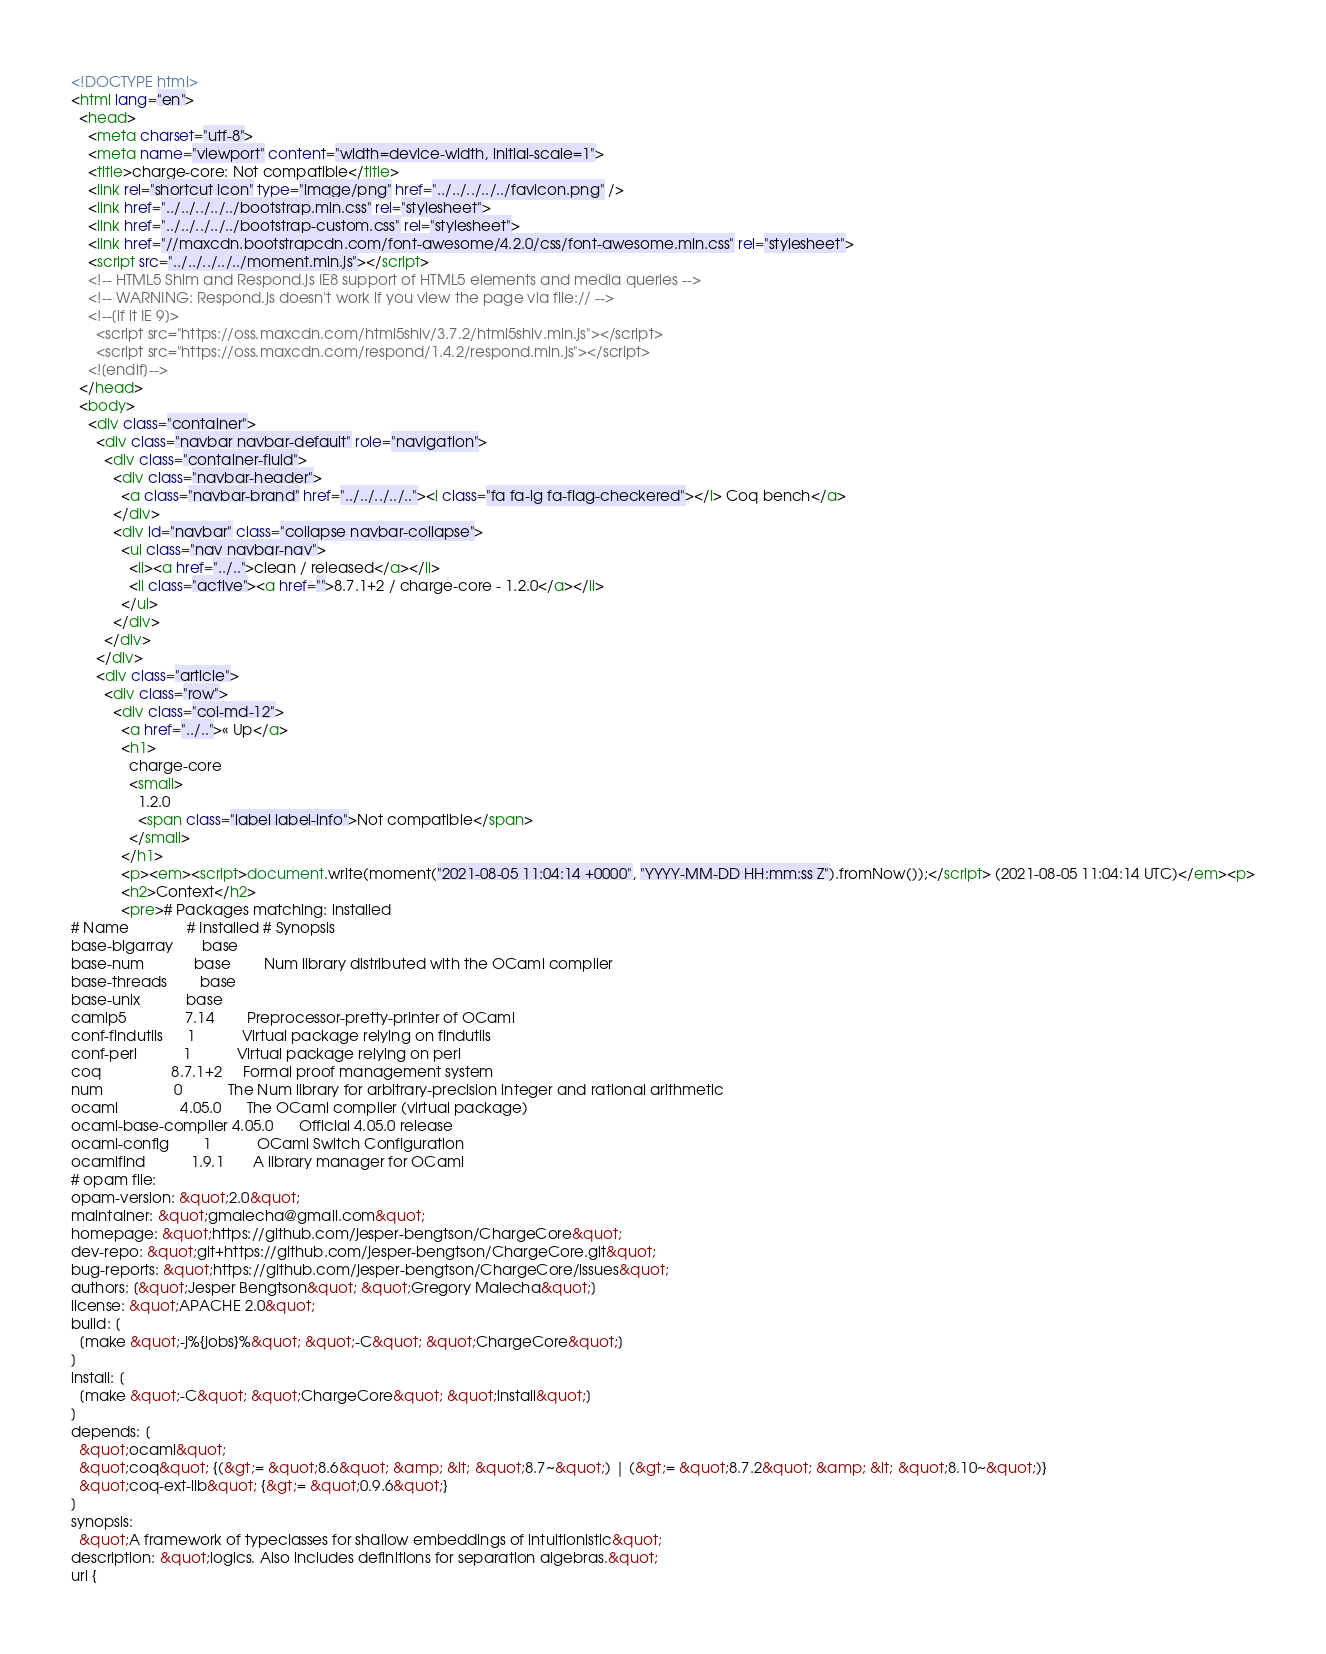Convert code to text. <code><loc_0><loc_0><loc_500><loc_500><_HTML_><!DOCTYPE html>
<html lang="en">
  <head>
    <meta charset="utf-8">
    <meta name="viewport" content="width=device-width, initial-scale=1">
    <title>charge-core: Not compatible</title>
    <link rel="shortcut icon" type="image/png" href="../../../../../favicon.png" />
    <link href="../../../../../bootstrap.min.css" rel="stylesheet">
    <link href="../../../../../bootstrap-custom.css" rel="stylesheet">
    <link href="//maxcdn.bootstrapcdn.com/font-awesome/4.2.0/css/font-awesome.min.css" rel="stylesheet">
    <script src="../../../../../moment.min.js"></script>
    <!-- HTML5 Shim and Respond.js IE8 support of HTML5 elements and media queries -->
    <!-- WARNING: Respond.js doesn't work if you view the page via file:// -->
    <!--[if lt IE 9]>
      <script src="https://oss.maxcdn.com/html5shiv/3.7.2/html5shiv.min.js"></script>
      <script src="https://oss.maxcdn.com/respond/1.4.2/respond.min.js"></script>
    <![endif]-->
  </head>
  <body>
    <div class="container">
      <div class="navbar navbar-default" role="navigation">
        <div class="container-fluid">
          <div class="navbar-header">
            <a class="navbar-brand" href="../../../../.."><i class="fa fa-lg fa-flag-checkered"></i> Coq bench</a>
          </div>
          <div id="navbar" class="collapse navbar-collapse">
            <ul class="nav navbar-nav">
              <li><a href="../..">clean / released</a></li>
              <li class="active"><a href="">8.7.1+2 / charge-core - 1.2.0</a></li>
            </ul>
          </div>
        </div>
      </div>
      <div class="article">
        <div class="row">
          <div class="col-md-12">
            <a href="../..">« Up</a>
            <h1>
              charge-core
              <small>
                1.2.0
                <span class="label label-info">Not compatible</span>
              </small>
            </h1>
            <p><em><script>document.write(moment("2021-08-05 11:04:14 +0000", "YYYY-MM-DD HH:mm:ss Z").fromNow());</script> (2021-08-05 11:04:14 UTC)</em><p>
            <h2>Context</h2>
            <pre># Packages matching: installed
# Name              # Installed # Synopsis
base-bigarray       base
base-num            base        Num library distributed with the OCaml compiler
base-threads        base
base-unix           base
camlp5              7.14        Preprocessor-pretty-printer of OCaml
conf-findutils      1           Virtual package relying on findutils
conf-perl           1           Virtual package relying on perl
coq                 8.7.1+2     Formal proof management system
num                 0           The Num library for arbitrary-precision integer and rational arithmetic
ocaml               4.05.0      The OCaml compiler (virtual package)
ocaml-base-compiler 4.05.0      Official 4.05.0 release
ocaml-config        1           OCaml Switch Configuration
ocamlfind           1.9.1       A library manager for OCaml
# opam file:
opam-version: &quot;2.0&quot;
maintainer: &quot;gmalecha@gmail.com&quot;
homepage: &quot;https://github.com/jesper-bengtson/ChargeCore&quot;
dev-repo: &quot;git+https://github.com/jesper-bengtson/ChargeCore.git&quot;
bug-reports: &quot;https://github.com/jesper-bengtson/ChargeCore/issues&quot;
authors: [&quot;Jesper Bengtson&quot; &quot;Gregory Malecha&quot;]
license: &quot;APACHE 2.0&quot;
build: [
  [make &quot;-j%{jobs}%&quot; &quot;-C&quot; &quot;ChargeCore&quot;]
]
install: [
  [make &quot;-C&quot; &quot;ChargeCore&quot; &quot;install&quot;]
]
depends: [
  &quot;ocaml&quot;
  &quot;coq&quot; {(&gt;= &quot;8.6&quot; &amp; &lt; &quot;8.7~&quot;) | (&gt;= &quot;8.7.2&quot; &amp; &lt; &quot;8.10~&quot;)}
  &quot;coq-ext-lib&quot; {&gt;= &quot;0.9.6&quot;}
]
synopsis:
  &quot;A framework of typeclasses for shallow embeddings of intuitionistic&quot;
description: &quot;logics. Also includes definitions for separation algebras.&quot;
url {</code> 